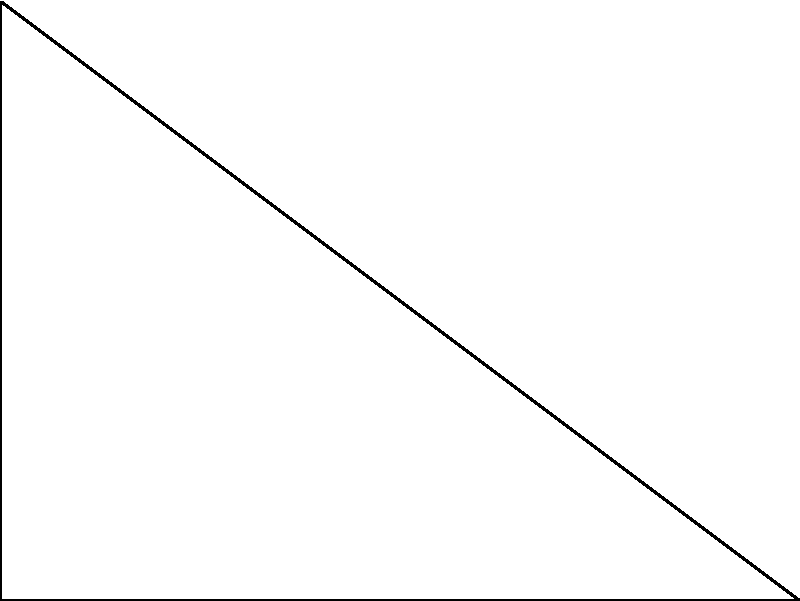In the right triangle ABC shown above, angle $\theta$ and its complement form two of the angles. Prove that the sum of the squares of the sine of these two angles is equal to 1. How does this relate to the Pythagorean theorem? Let's approach this step-by-step:

1) In a right triangle, we have two acute angles that are complementary, meaning they sum to 90°. Let's call these angles $\theta$ and $(90° - \theta)$.

2) We need to prove that $\sin^2(\theta) + \sin^2(90° - \theta) = 1$.

3) Recall the trigonometric identity: $\sin(90° - \theta) = \cos(\theta)$

4) Substituting this into our equation:
   $\sin^2(\theta) + \sin^2(90° - \theta) = \sin^2(\theta) + \cos^2(\theta)$

5) Now, we can use the fundamental trigonometric identity:
   $\sin^2(\theta) + \cos^2(\theta) = 1$

6) This proves our statement.

7) To relate this to the Pythagorean theorem, let's consider the sides of the triangle:
   - $\sin(\theta) = \frac{\text{opposite}}{\text{hypotenuse}} = \frac{a}{c}$
   - $\cos(\theta) = \frac{\text{adjacent}}{\text{hypotenuse}} = \frac{b}{c}$

8) Substituting these into our proven equation:
   $(\frac{a}{c})^2 + (\frac{b}{c})^2 = 1$

9) Multiplying both sides by $c^2$:
   $a^2 + b^2 = c^2$

This is the Pythagorean theorem. Thus, our trigonometric identity is equivalent to the Pythagorean theorem in right triangles.
Answer: $\sin^2(\theta) + \cos^2(\theta) = 1$ is equivalent to $a^2 + b^2 = c^2$ in right triangles. 